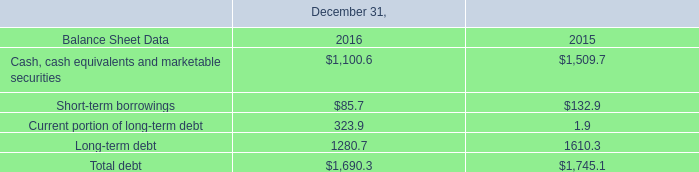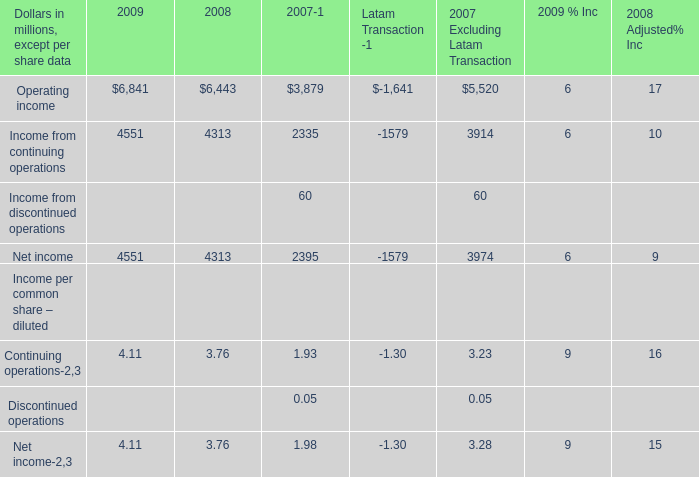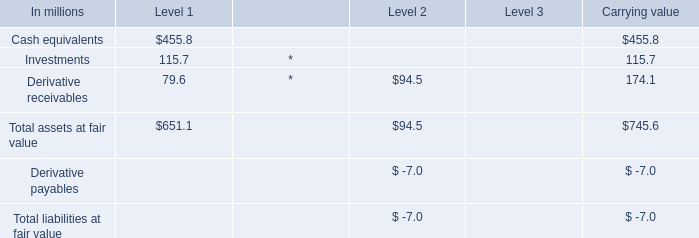What's the average of Operating income of 2007 Excluding Latam Transaction, and Cash, cash equivalents and marketable securities of December 31, 2016 ? 
Computations: ((5520.0 + 1100.6) / 2)
Answer: 3310.3. 